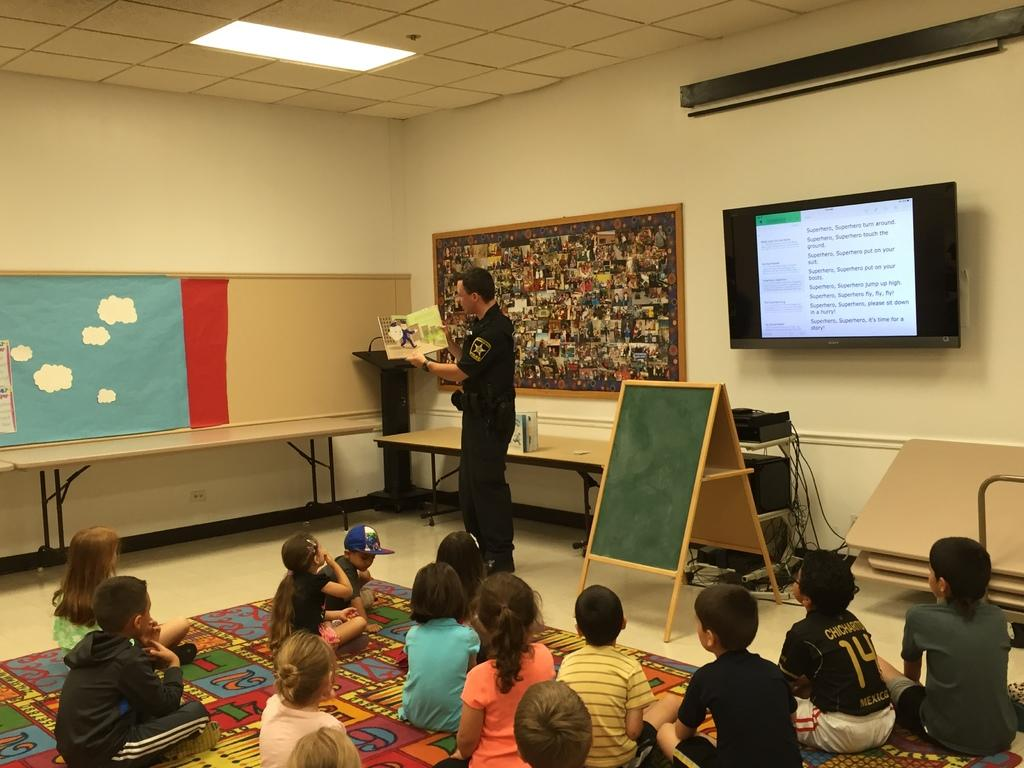What are the children in the image doing? The group of children is sitting on the floor. What is the man holding in the image? The man is standing and holding a book. What can be seen at the back side of the image? There is a television and a board at the back side. What piece of furniture is present in the image? There is a table in the image. Can you see the mother of the children in the image? There is no mother of the children present in the image. What type of window is visible in the image? There is no window visible in the image. 